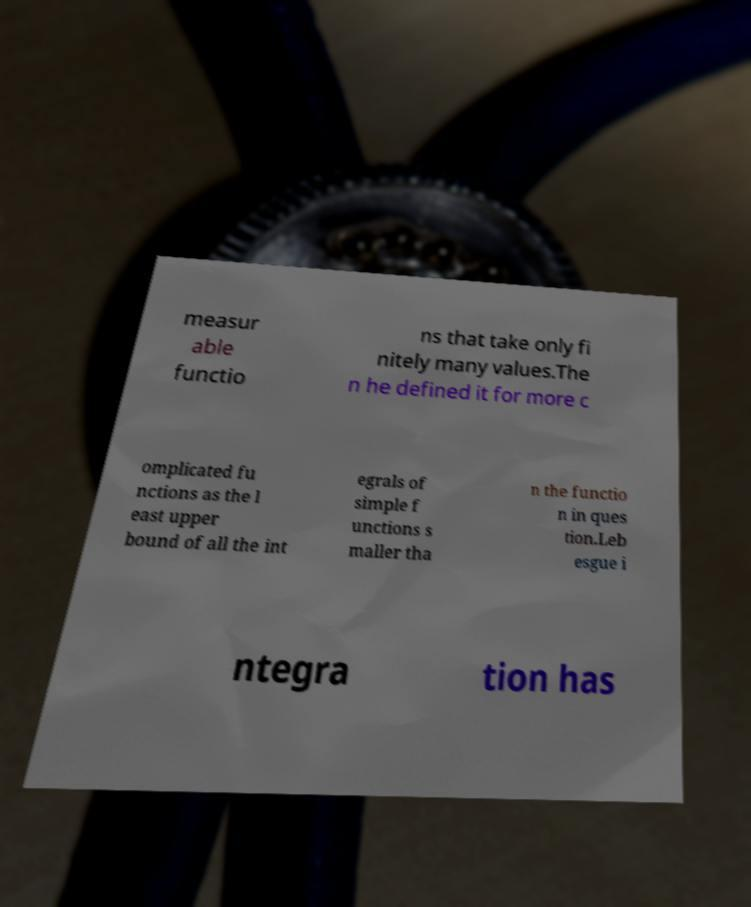Please read and relay the text visible in this image. What does it say? measur able functio ns that take only fi nitely many values.The n he defined it for more c omplicated fu nctions as the l east upper bound of all the int egrals of simple f unctions s maller tha n the functio n in ques tion.Leb esgue i ntegra tion has 